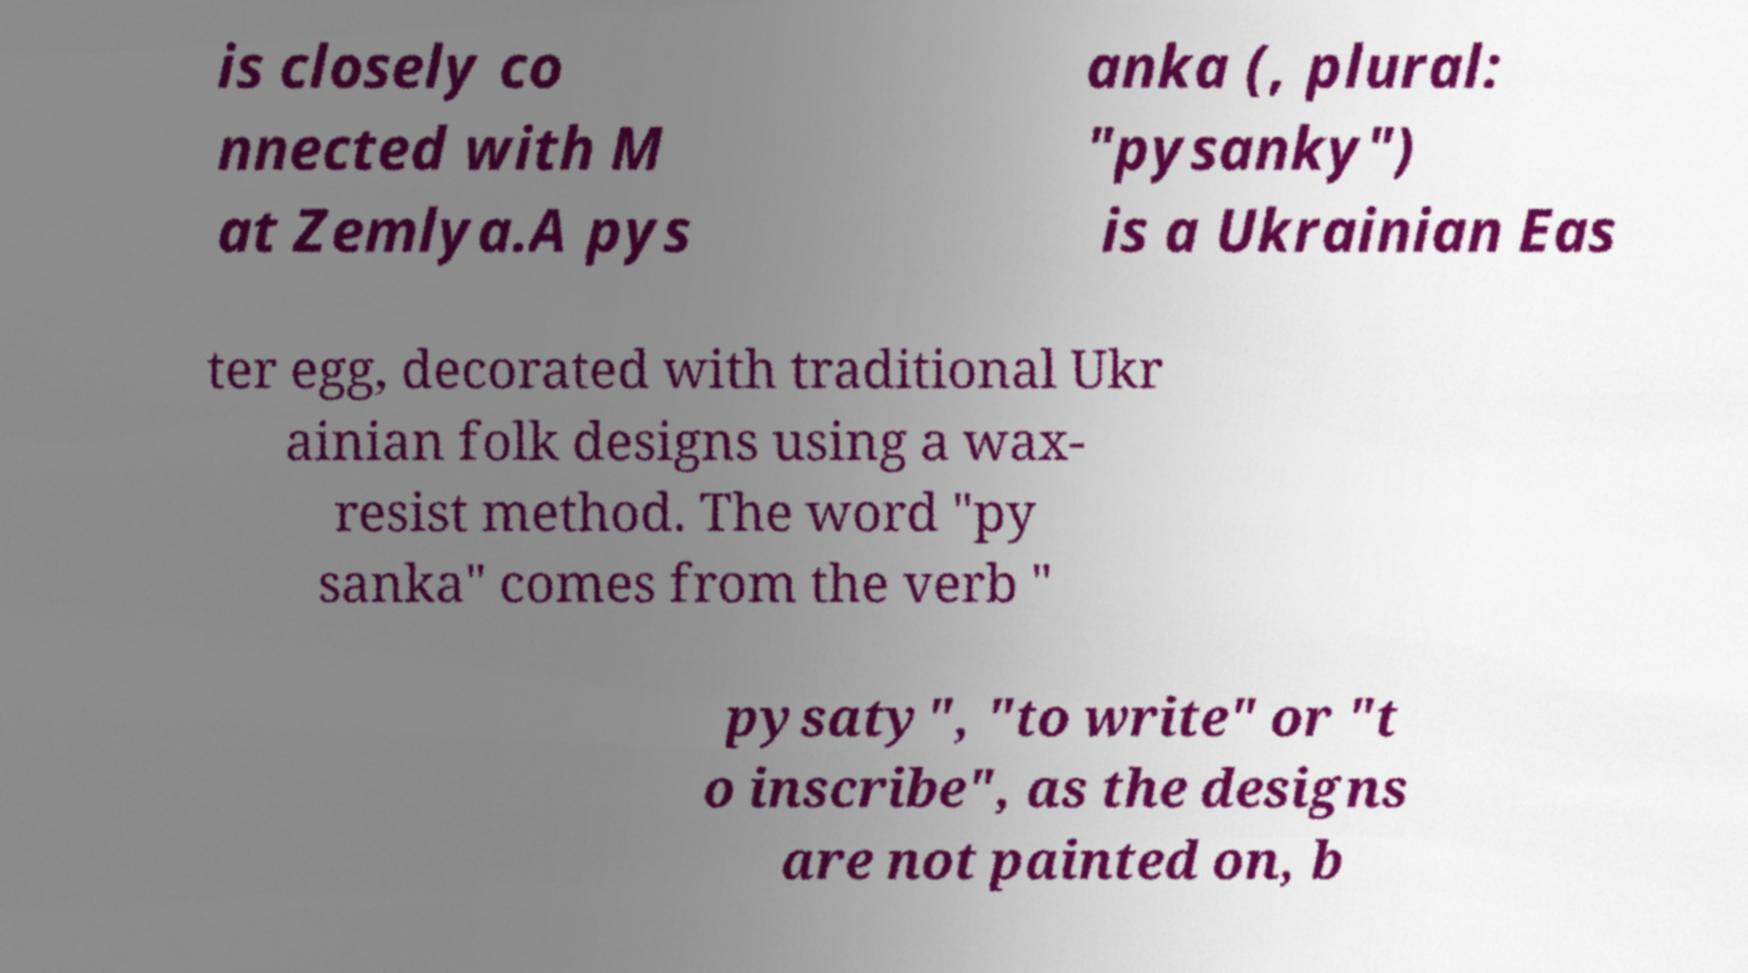For documentation purposes, I need the text within this image transcribed. Could you provide that? is closely co nnected with M at Zemlya.A pys anka (, plural: "pysanky") is a Ukrainian Eas ter egg, decorated with traditional Ukr ainian folk designs using a wax- resist method. The word "py sanka" comes from the verb " pysaty", "to write" or "t o inscribe", as the designs are not painted on, b 